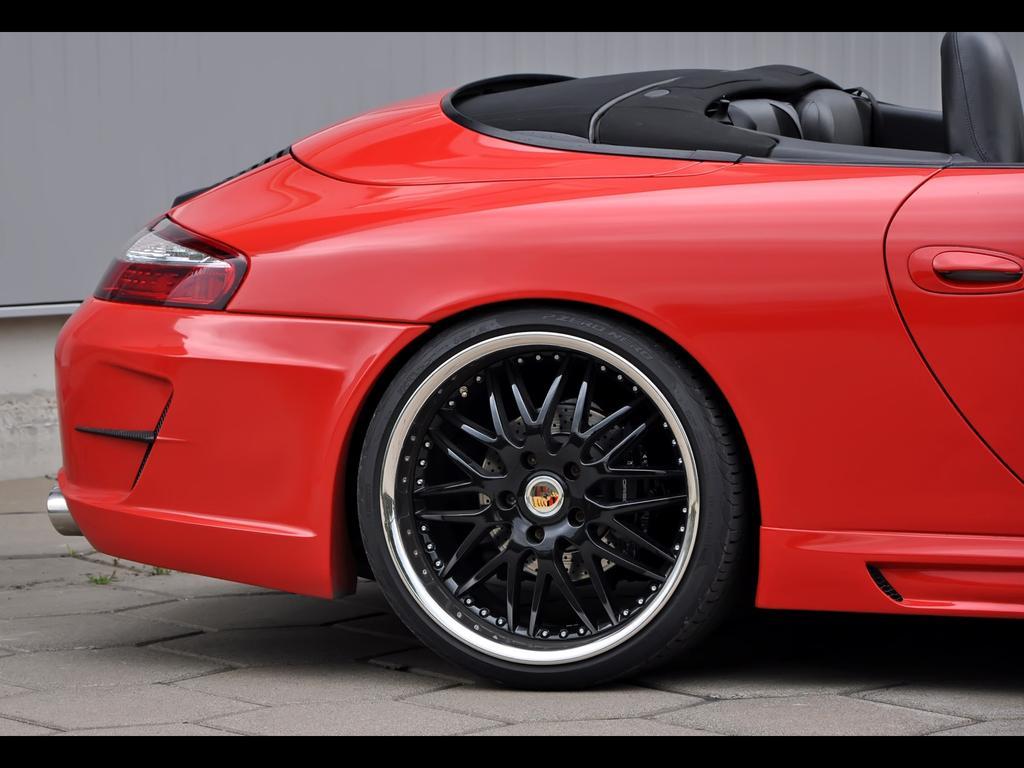In one or two sentences, can you explain what this image depicts? In this image there is a red color car on the road and the image has black borders. 